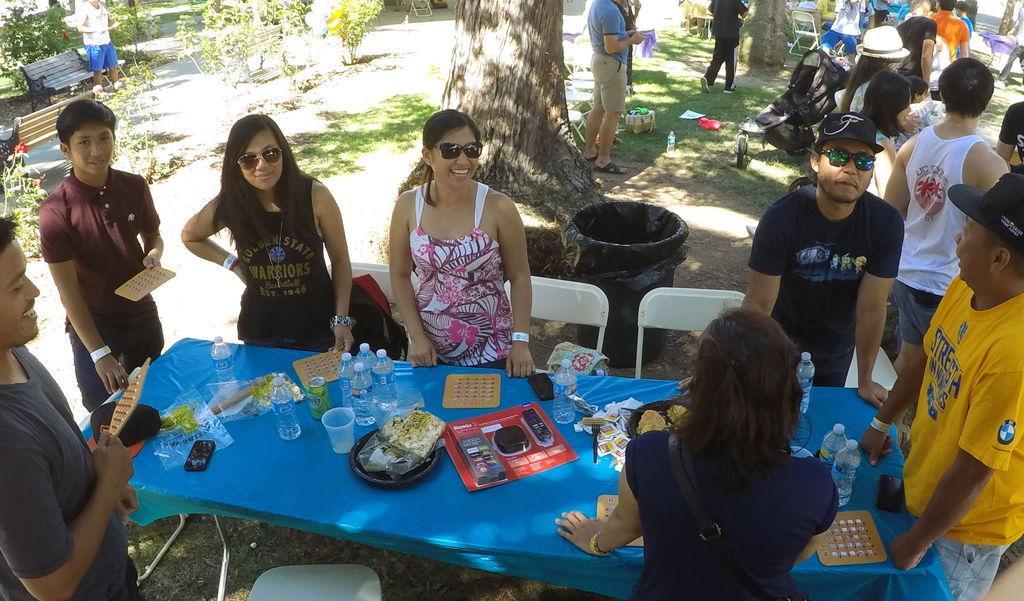Could you give a brief overview of what you see in this image? there is a blue table on which there are bottles, glass, tin and other objects. people are standing surrounded by the table. there are white chairs. at the back there is a black trash bin, a tree trunk. other more people are standing at the back. at the left there is a wooden bench and a person is standing in front of it. 